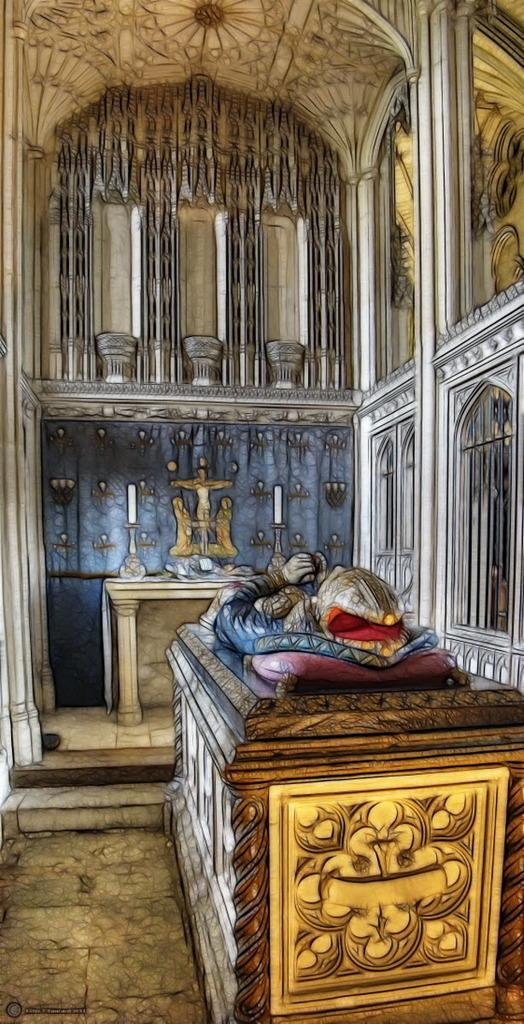What is depicted in the sketch in the image? There is a sketch of a person sleeping on a bed in the image. What objects can be seen in addition to the sketch? There are candles, a statue, a table, and a wall in the image. What type of patch is being sold at the store in the image? There is no store or patch present in the image. How hot is the temperature in the room depicted in the image? The image does not provide information about the temperature in the room. 